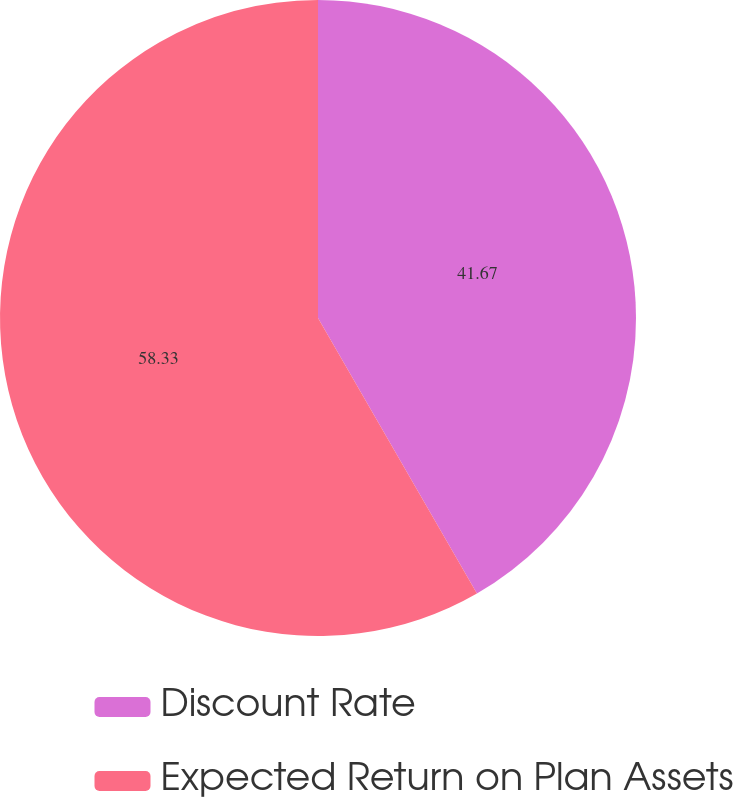Convert chart. <chart><loc_0><loc_0><loc_500><loc_500><pie_chart><fcel>Discount Rate<fcel>Expected Return on Plan Assets<nl><fcel>41.67%<fcel>58.33%<nl></chart> 